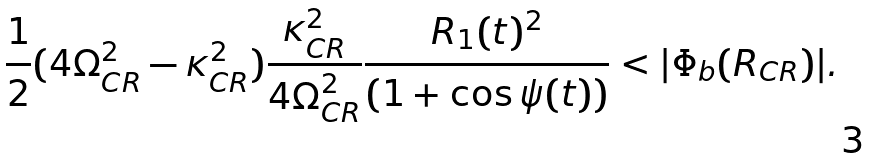<formula> <loc_0><loc_0><loc_500><loc_500>\frac { 1 } { 2 } ( 4 \Omega _ { C R } ^ { 2 } - \kappa _ { C R } ^ { 2 } ) \frac { \kappa _ { C R } ^ { 2 } } { 4 \Omega _ { C R } ^ { 2 } } \frac { R _ { 1 } ( t ) ^ { 2 } } { ( 1 + \cos \psi ( t ) ) } < | \Phi _ { b } ( R _ { C R } ) | .</formula> 